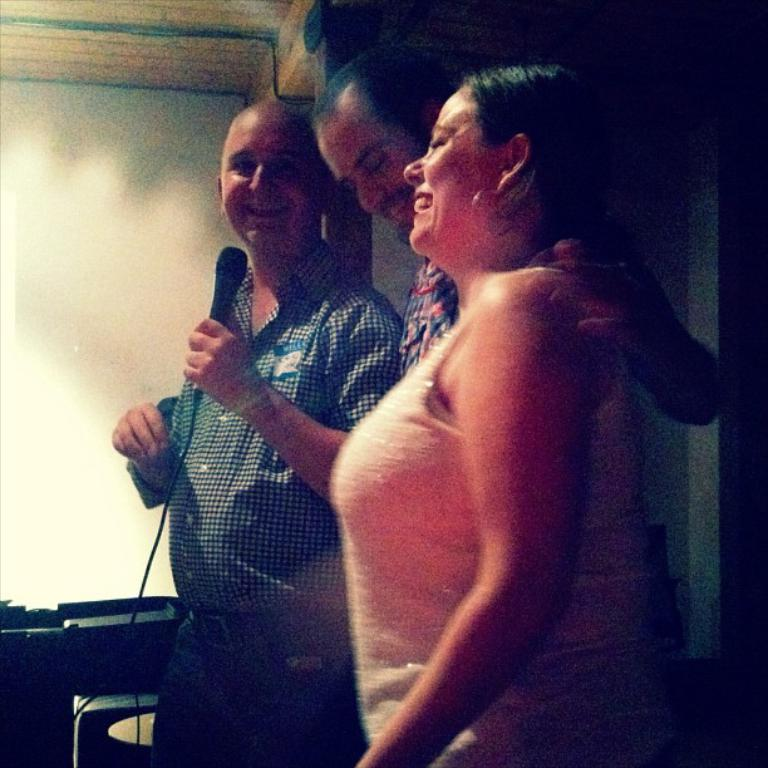How many people are in the image? There are three persons in the image. What is one of the persons holding in his hand? One of the persons is holding a mic in his hand. Can you describe any other objects or features in the background of the image? Unfortunately, the provided facts do not give any information about the objects or features in the background of the image. What type of tree can be seen in the image? There is no tree present in the image. How many shops are visible in the image? There is no information about shops in the provided facts, so we cannot answer any questions about them. 